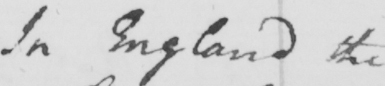Please transcribe the handwritten text in this image. In England the 